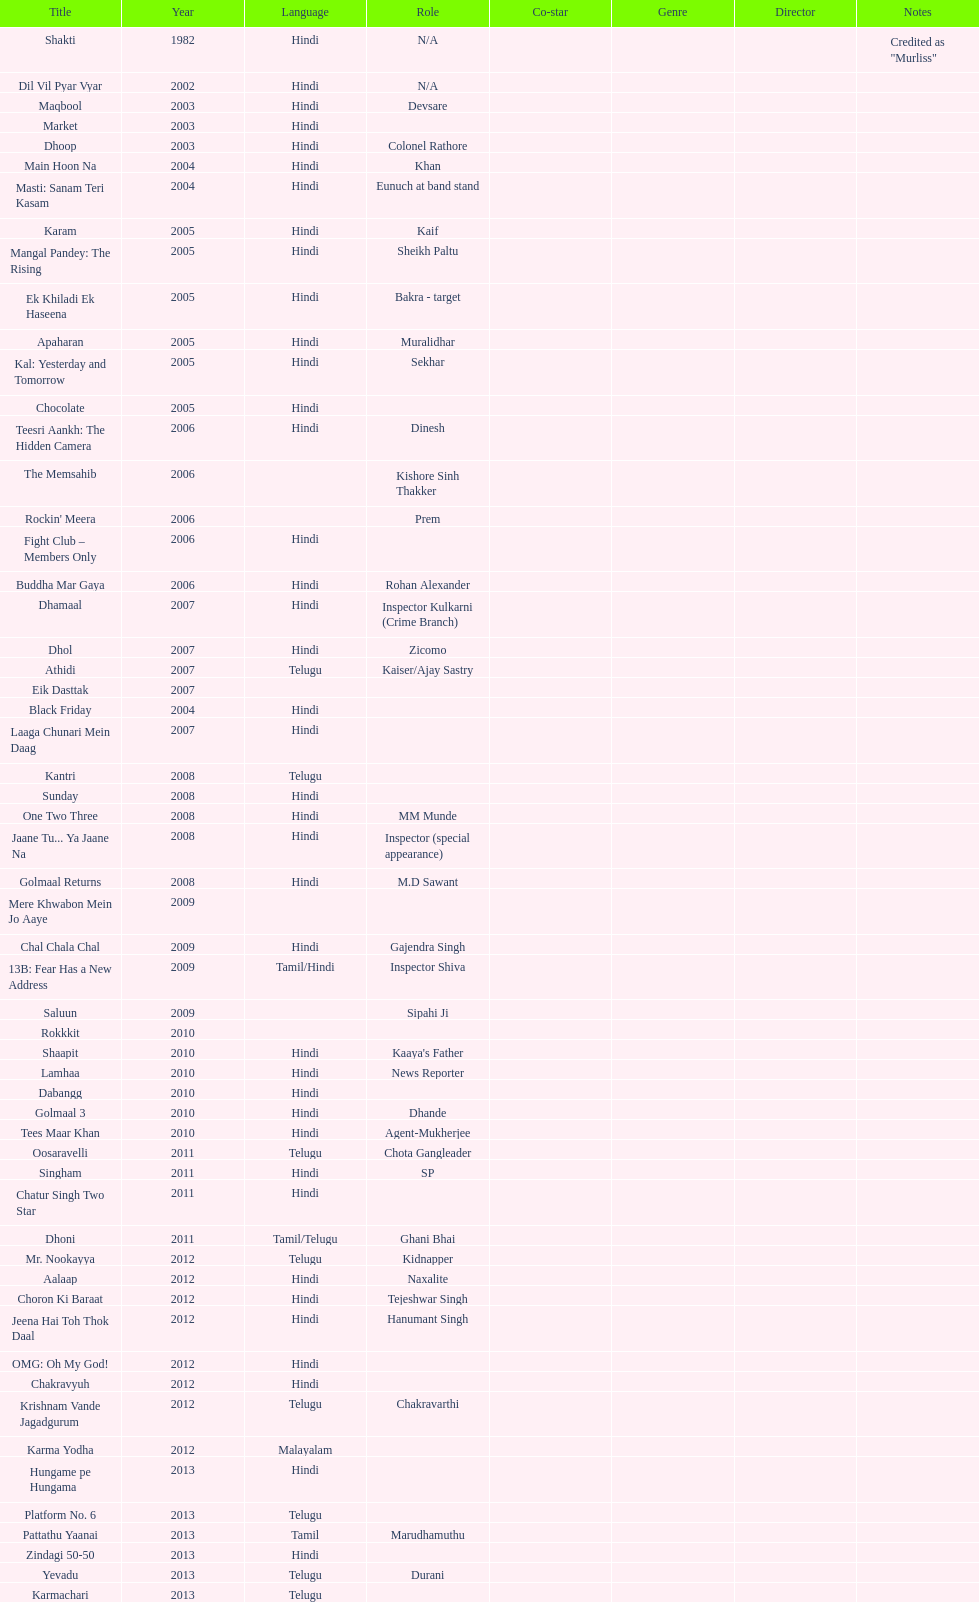What is the total years on the chart 13. 